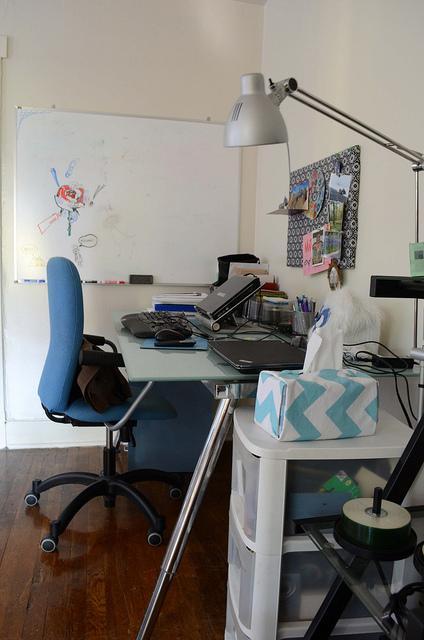How many people are wearing pink hats?
Give a very brief answer. 0. 